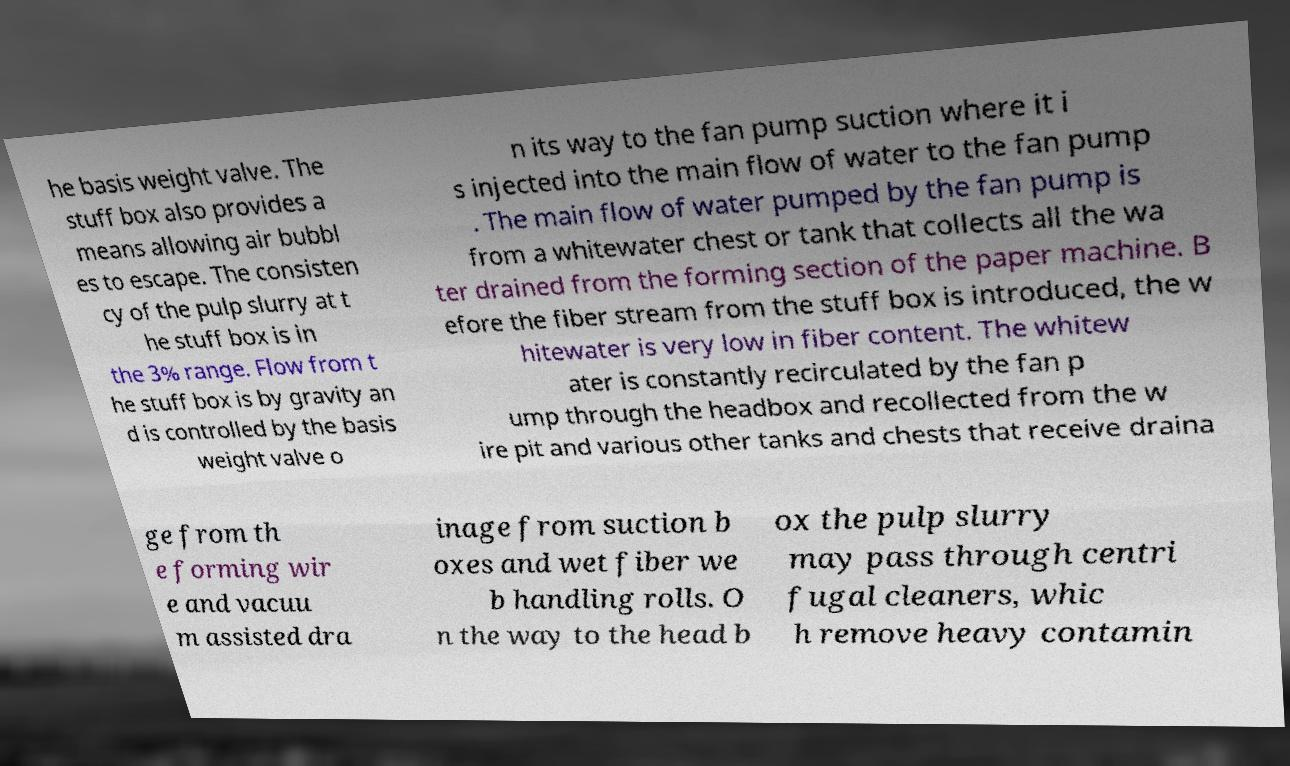I need the written content from this picture converted into text. Can you do that? he basis weight valve. The stuff box also provides a means allowing air bubbl es to escape. The consisten cy of the pulp slurry at t he stuff box is in the 3% range. Flow from t he stuff box is by gravity an d is controlled by the basis weight valve o n its way to the fan pump suction where it i s injected into the main flow of water to the fan pump . The main flow of water pumped by the fan pump is from a whitewater chest or tank that collects all the wa ter drained from the forming section of the paper machine. B efore the fiber stream from the stuff box is introduced, the w hitewater is very low in fiber content. The whitew ater is constantly recirculated by the fan p ump through the headbox and recollected from the w ire pit and various other tanks and chests that receive draina ge from th e forming wir e and vacuu m assisted dra inage from suction b oxes and wet fiber we b handling rolls. O n the way to the head b ox the pulp slurry may pass through centri fugal cleaners, whic h remove heavy contamin 